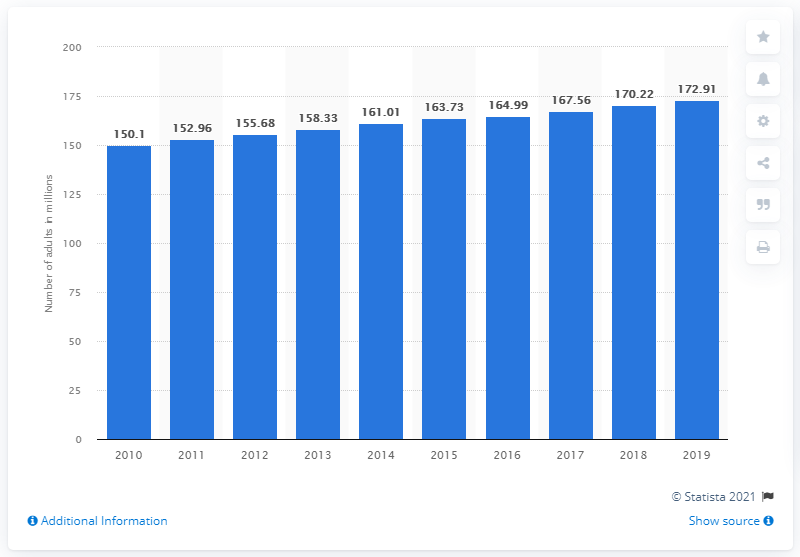Indicate a few pertinent items in this graphic. In 2019, there were 172.91 adults in Indonesia. 